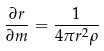<formula> <loc_0><loc_0><loc_500><loc_500>\frac { \partial r } { \partial m } = \frac { 1 } { 4 \pi r ^ { 2 } \rho }</formula> 